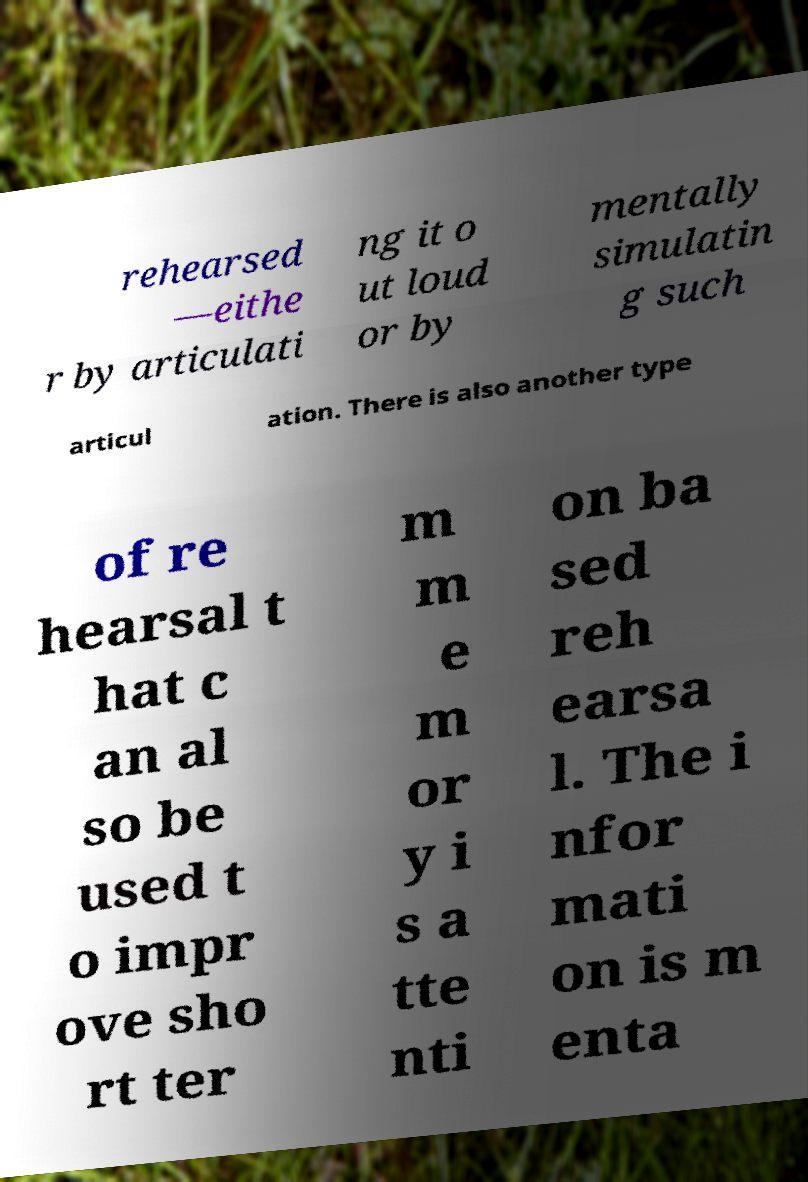There's text embedded in this image that I need extracted. Can you transcribe it verbatim? rehearsed —eithe r by articulati ng it o ut loud or by mentally simulatin g such articul ation. There is also another type of re hearsal t hat c an al so be used t o impr ove sho rt ter m m e m or y i s a tte nti on ba sed reh earsa l. The i nfor mati on is m enta 